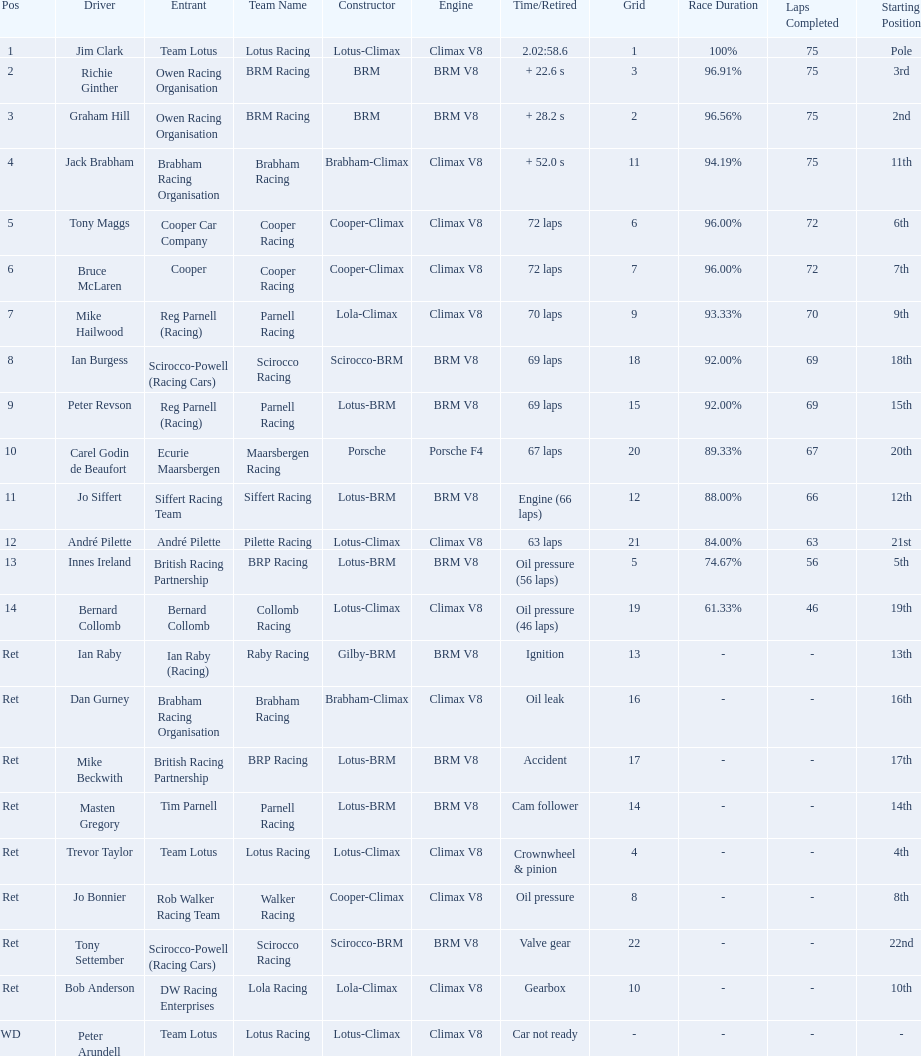Who all drive cars that were constructed bur climax? Jim Clark, Jack Brabham, Tony Maggs, Bruce McLaren, Mike Hailwood, André Pilette, Bernard Collomb, Dan Gurney, Trevor Taylor, Jo Bonnier, Bob Anderson, Peter Arundell. Which driver's climax constructed cars started in the top 10 on the grid? Jim Clark, Tony Maggs, Bruce McLaren, Mike Hailwood, Jo Bonnier, Bob Anderson. Of the top 10 starting climax constructed drivers, which ones did not finish the race? Jo Bonnier, Bob Anderson. What was the failure that was engine related that took out the driver of the climax constructed car that did not finish even though it started in the top 10? Oil pressure. 